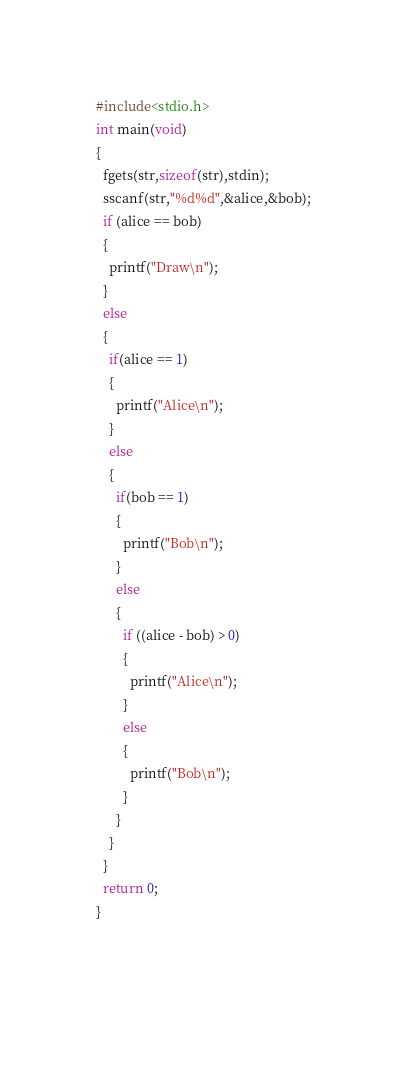<code> <loc_0><loc_0><loc_500><loc_500><_C_>#include<stdio.h>
int main(void)
{
  fgets(str,sizeof(str),stdin);
  sscanf(str,"%d%d",&alice,&bob);
  if (alice == bob)
  {
    printf("Draw\n");
  }
  else
  {
    if(alice == 1)
    {
      printf("Alice\n");
    }
    else
    {
      if(bob == 1)
      {
        printf("Bob\n");
      }
      else
      {
        if ((alice - bob) > 0)
        {
          printf("Alice\n");
        }
        else
        {
          printf("Bob\n");
        }
      }
    }
  }
  return 0;
}
                 
  </code> 